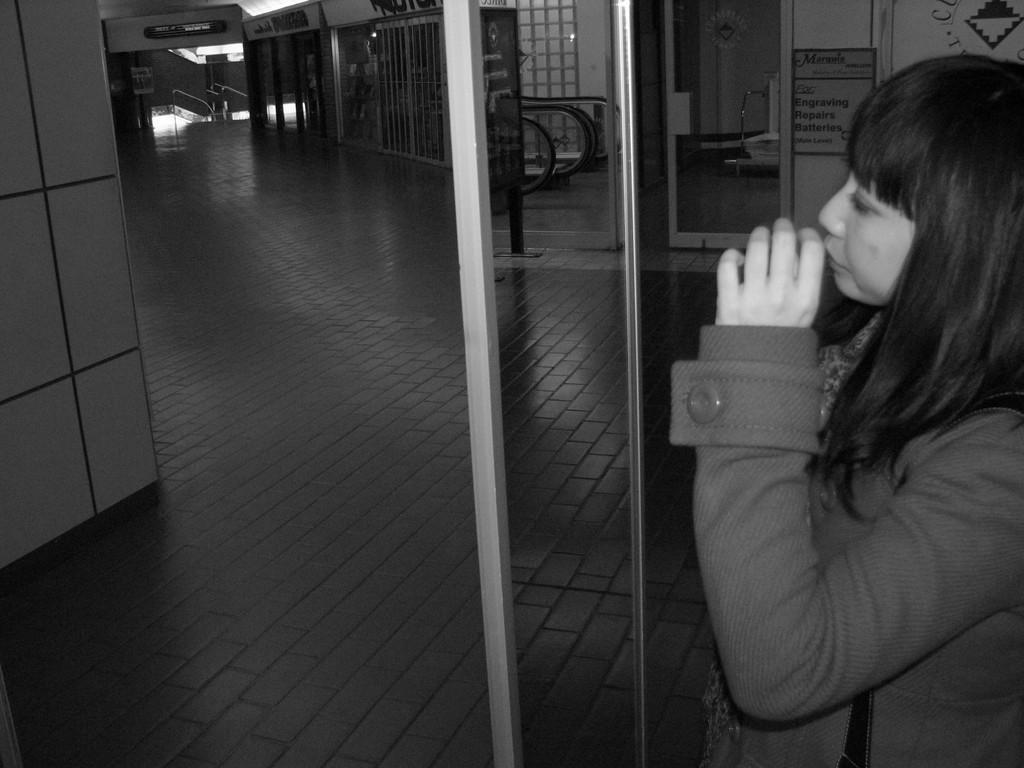What is the color scheme of the image? The image is black and white. Who or what can be seen in the image? There is a woman standing in the image. What object is present in the image that might be used for drinking? There is a glass in the image. What architectural feature is visible in the image? There is a door in the image. What material is present in the image that might be used for construction or signage? identifying the main subject in the image, which is the woman. Then, we expand the conversation to include other items that are also visible, such as the glass, door, boards, floor, and wall. Each question is designed to elicit a specific detail about the image that is known from the provided facts. Can you see any steam coming from the woman's cup in the image? There is no cup present in the image, and therefore no steam can be observed. Is there a giraffe visible in the image? No, there is no giraffe present in the image. 